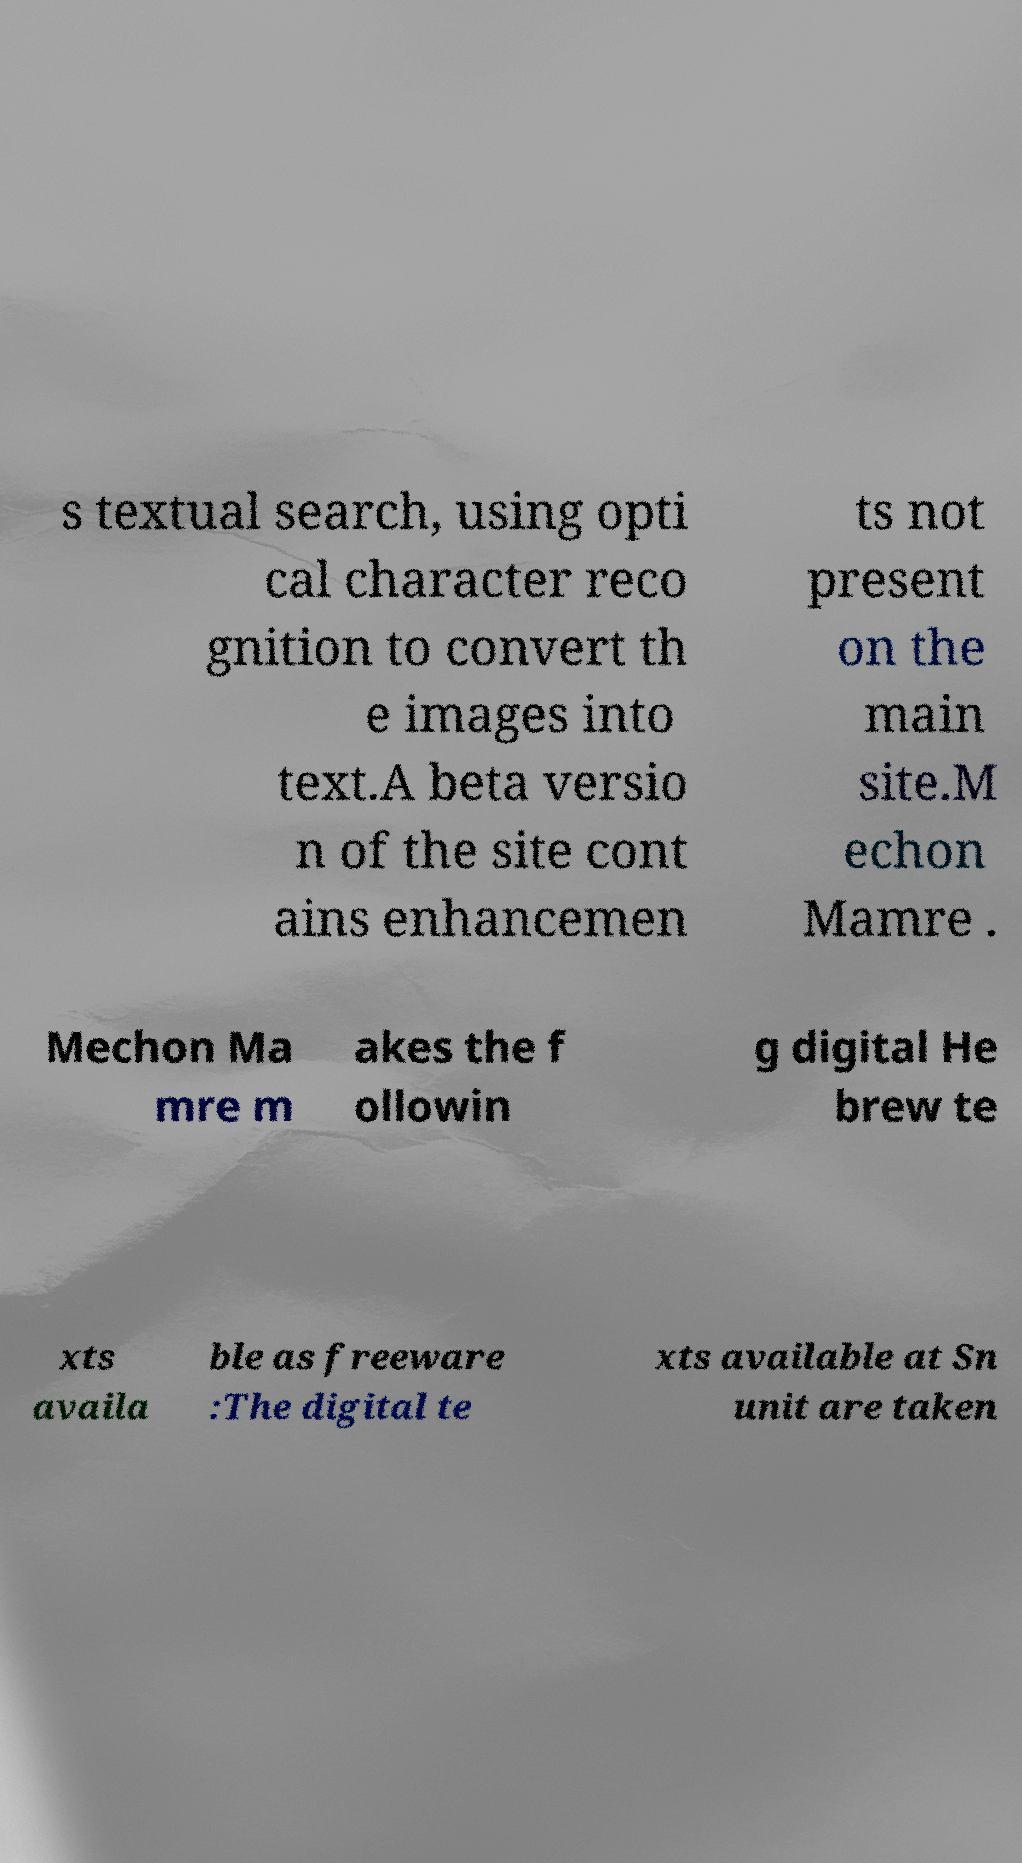There's text embedded in this image that I need extracted. Can you transcribe it verbatim? s textual search, using opti cal character reco gnition to convert th e images into text.A beta versio n of the site cont ains enhancemen ts not present on the main site.M echon Mamre . Mechon Ma mre m akes the f ollowin g digital He brew te xts availa ble as freeware :The digital te xts available at Sn unit are taken 